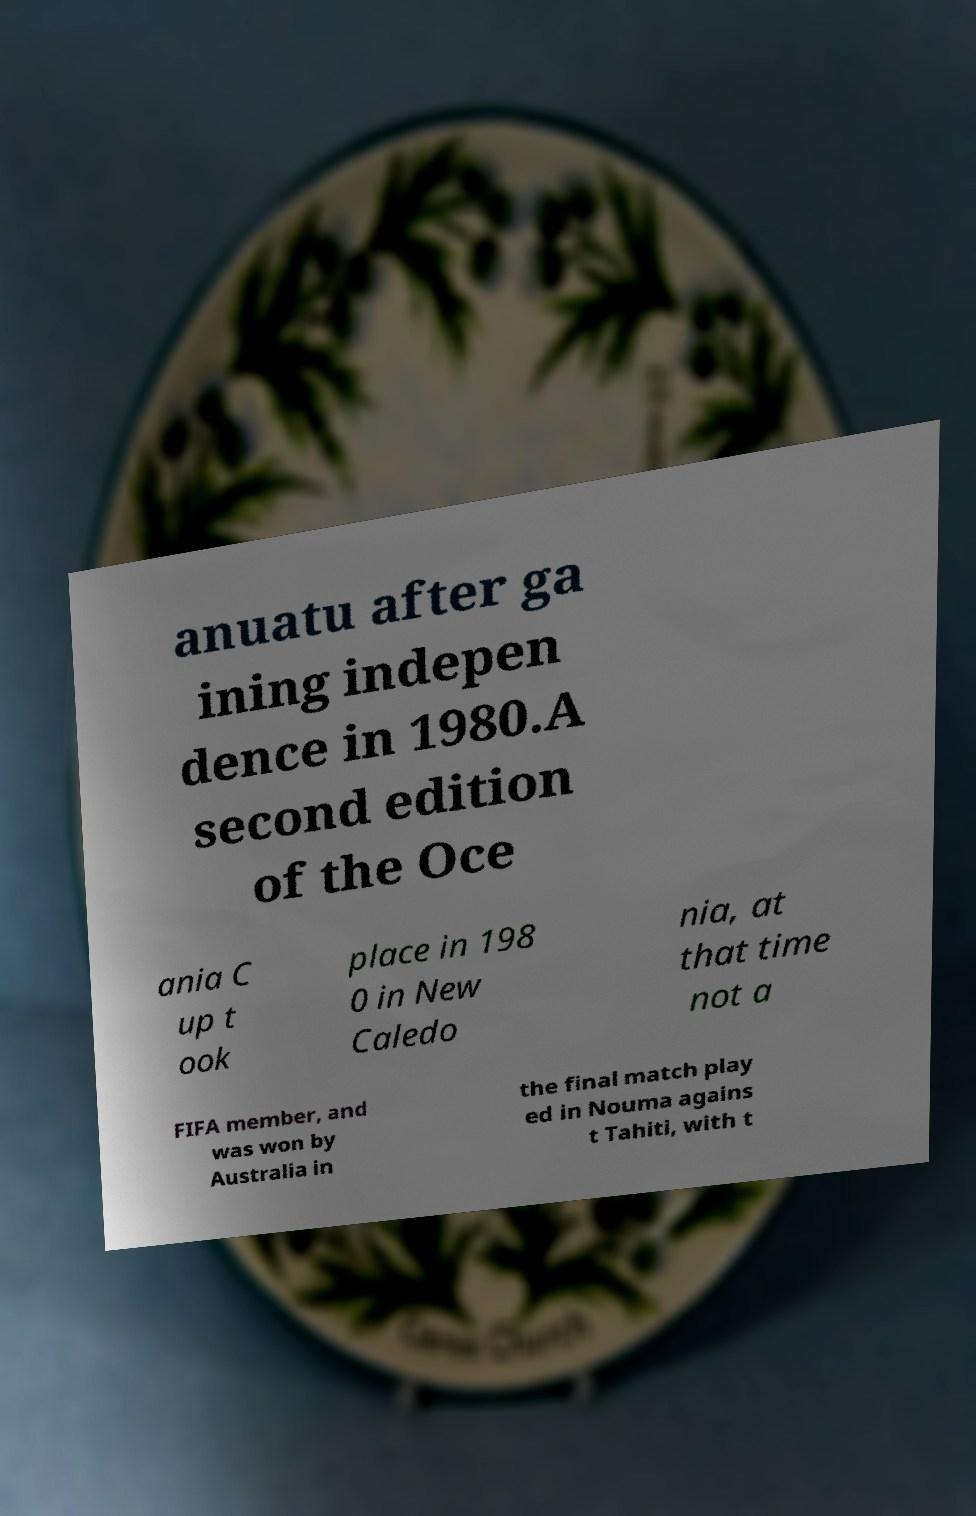There's text embedded in this image that I need extracted. Can you transcribe it verbatim? anuatu after ga ining indepen dence in 1980.A second edition of the Oce ania C up t ook place in 198 0 in New Caledo nia, at that time not a FIFA member, and was won by Australia in the final match play ed in Nouma agains t Tahiti, with t 